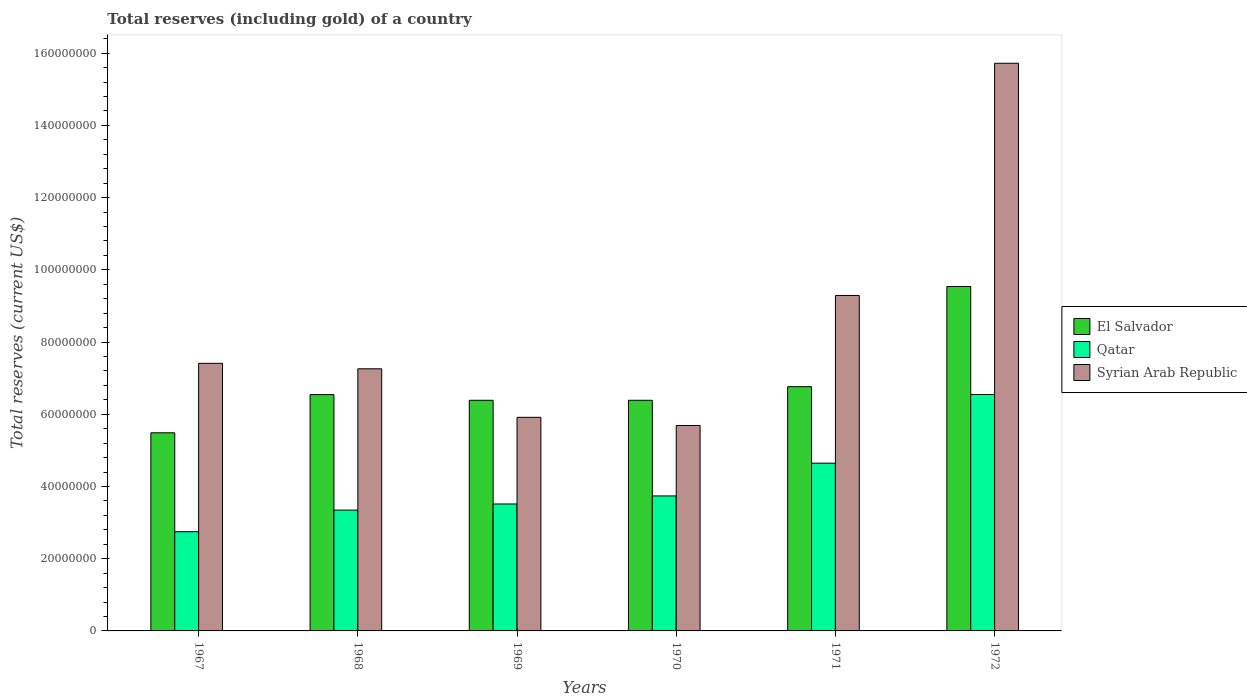How many groups of bars are there?
Ensure brevity in your answer.  6. Are the number of bars per tick equal to the number of legend labels?
Your answer should be compact. Yes. Are the number of bars on each tick of the X-axis equal?
Make the answer very short. Yes. What is the label of the 3rd group of bars from the left?
Ensure brevity in your answer.  1969. In how many cases, is the number of bars for a given year not equal to the number of legend labels?
Keep it short and to the point. 0. What is the total reserves (including gold) in Syrian Arab Republic in 1972?
Your answer should be compact. 1.57e+08. Across all years, what is the maximum total reserves (including gold) in Syrian Arab Republic?
Ensure brevity in your answer.  1.57e+08. Across all years, what is the minimum total reserves (including gold) in Syrian Arab Republic?
Provide a succinct answer. 5.69e+07. In which year was the total reserves (including gold) in Qatar maximum?
Offer a terse response. 1972. What is the total total reserves (including gold) in Syrian Arab Republic in the graph?
Keep it short and to the point. 5.13e+08. What is the difference between the total reserves (including gold) in Syrian Arab Republic in 1967 and that in 1972?
Your answer should be compact. -8.31e+07. What is the difference between the total reserves (including gold) in Qatar in 1968 and the total reserves (including gold) in Syrian Arab Republic in 1969?
Provide a short and direct response. -2.57e+07. What is the average total reserves (including gold) in Qatar per year?
Provide a short and direct response. 4.09e+07. In the year 1971, what is the difference between the total reserves (including gold) in El Salvador and total reserves (including gold) in Syrian Arab Republic?
Give a very brief answer. -2.53e+07. In how many years, is the total reserves (including gold) in Syrian Arab Republic greater than 24000000 US$?
Your answer should be very brief. 6. What is the ratio of the total reserves (including gold) in El Salvador in 1968 to that in 1971?
Your answer should be very brief. 0.97. What is the difference between the highest and the second highest total reserves (including gold) in Syrian Arab Republic?
Offer a very short reply. 6.43e+07. What is the difference between the highest and the lowest total reserves (including gold) in Syrian Arab Republic?
Provide a succinct answer. 1.00e+08. Is the sum of the total reserves (including gold) in Qatar in 1967 and 1972 greater than the maximum total reserves (including gold) in El Salvador across all years?
Offer a very short reply. No. What does the 3rd bar from the left in 1967 represents?
Provide a short and direct response. Syrian Arab Republic. What does the 2nd bar from the right in 1970 represents?
Offer a terse response. Qatar. How many bars are there?
Your response must be concise. 18. Are all the bars in the graph horizontal?
Your answer should be compact. No. Are the values on the major ticks of Y-axis written in scientific E-notation?
Provide a succinct answer. No. Does the graph contain any zero values?
Keep it short and to the point. No. Does the graph contain grids?
Ensure brevity in your answer.  No. Where does the legend appear in the graph?
Provide a short and direct response. Center right. How many legend labels are there?
Give a very brief answer. 3. How are the legend labels stacked?
Your answer should be very brief. Vertical. What is the title of the graph?
Provide a succinct answer. Total reserves (including gold) of a country. Does "Kosovo" appear as one of the legend labels in the graph?
Provide a succinct answer. No. What is the label or title of the Y-axis?
Offer a terse response. Total reserves (current US$). What is the Total reserves (current US$) in El Salvador in 1967?
Your response must be concise. 5.49e+07. What is the Total reserves (current US$) of Qatar in 1967?
Provide a short and direct response. 2.75e+07. What is the Total reserves (current US$) of Syrian Arab Republic in 1967?
Make the answer very short. 7.41e+07. What is the Total reserves (current US$) of El Salvador in 1968?
Keep it short and to the point. 6.54e+07. What is the Total reserves (current US$) of Qatar in 1968?
Make the answer very short. 3.35e+07. What is the Total reserves (current US$) of Syrian Arab Republic in 1968?
Your answer should be compact. 7.26e+07. What is the Total reserves (current US$) of El Salvador in 1969?
Make the answer very short. 6.39e+07. What is the Total reserves (current US$) of Qatar in 1969?
Provide a succinct answer. 3.52e+07. What is the Total reserves (current US$) in Syrian Arab Republic in 1969?
Provide a short and direct response. 5.92e+07. What is the Total reserves (current US$) of El Salvador in 1970?
Keep it short and to the point. 6.39e+07. What is the Total reserves (current US$) in Qatar in 1970?
Ensure brevity in your answer.  3.74e+07. What is the Total reserves (current US$) in Syrian Arab Republic in 1970?
Provide a short and direct response. 5.69e+07. What is the Total reserves (current US$) in El Salvador in 1971?
Give a very brief answer. 6.76e+07. What is the Total reserves (current US$) in Qatar in 1971?
Make the answer very short. 4.65e+07. What is the Total reserves (current US$) in Syrian Arab Republic in 1971?
Offer a terse response. 9.29e+07. What is the Total reserves (current US$) in El Salvador in 1972?
Offer a very short reply. 9.54e+07. What is the Total reserves (current US$) of Qatar in 1972?
Provide a succinct answer. 6.55e+07. What is the Total reserves (current US$) of Syrian Arab Republic in 1972?
Keep it short and to the point. 1.57e+08. Across all years, what is the maximum Total reserves (current US$) of El Salvador?
Your answer should be compact. 9.54e+07. Across all years, what is the maximum Total reserves (current US$) of Qatar?
Offer a very short reply. 6.55e+07. Across all years, what is the maximum Total reserves (current US$) in Syrian Arab Republic?
Make the answer very short. 1.57e+08. Across all years, what is the minimum Total reserves (current US$) in El Salvador?
Your response must be concise. 5.49e+07. Across all years, what is the minimum Total reserves (current US$) in Qatar?
Offer a very short reply. 2.75e+07. Across all years, what is the minimum Total reserves (current US$) of Syrian Arab Republic?
Provide a short and direct response. 5.69e+07. What is the total Total reserves (current US$) of El Salvador in the graph?
Offer a terse response. 4.11e+08. What is the total Total reserves (current US$) in Qatar in the graph?
Ensure brevity in your answer.  2.45e+08. What is the total Total reserves (current US$) of Syrian Arab Republic in the graph?
Make the answer very short. 5.13e+08. What is the difference between the Total reserves (current US$) of El Salvador in 1967 and that in 1968?
Your response must be concise. -1.06e+07. What is the difference between the Total reserves (current US$) in Qatar in 1967 and that in 1968?
Offer a very short reply. -5.99e+06. What is the difference between the Total reserves (current US$) in Syrian Arab Republic in 1967 and that in 1968?
Your answer should be compact. 1.51e+06. What is the difference between the Total reserves (current US$) of El Salvador in 1967 and that in 1969?
Your answer should be very brief. -9.00e+06. What is the difference between the Total reserves (current US$) in Qatar in 1967 and that in 1969?
Keep it short and to the point. -7.68e+06. What is the difference between the Total reserves (current US$) in Syrian Arab Republic in 1967 and that in 1969?
Provide a succinct answer. 1.50e+07. What is the difference between the Total reserves (current US$) of El Salvador in 1967 and that in 1970?
Keep it short and to the point. -9.00e+06. What is the difference between the Total reserves (current US$) of Qatar in 1967 and that in 1970?
Your response must be concise. -9.91e+06. What is the difference between the Total reserves (current US$) of Syrian Arab Republic in 1967 and that in 1970?
Your answer should be very brief. 1.72e+07. What is the difference between the Total reserves (current US$) of El Salvador in 1967 and that in 1971?
Your response must be concise. -1.28e+07. What is the difference between the Total reserves (current US$) of Qatar in 1967 and that in 1971?
Your response must be concise. -1.90e+07. What is the difference between the Total reserves (current US$) in Syrian Arab Republic in 1967 and that in 1971?
Ensure brevity in your answer.  -1.88e+07. What is the difference between the Total reserves (current US$) of El Salvador in 1967 and that in 1972?
Provide a succinct answer. -4.05e+07. What is the difference between the Total reserves (current US$) of Qatar in 1967 and that in 1972?
Your answer should be compact. -3.80e+07. What is the difference between the Total reserves (current US$) in Syrian Arab Republic in 1967 and that in 1972?
Offer a very short reply. -8.31e+07. What is the difference between the Total reserves (current US$) in El Salvador in 1968 and that in 1969?
Your response must be concise. 1.57e+06. What is the difference between the Total reserves (current US$) in Qatar in 1968 and that in 1969?
Your answer should be compact. -1.69e+06. What is the difference between the Total reserves (current US$) of Syrian Arab Republic in 1968 and that in 1969?
Offer a terse response. 1.34e+07. What is the difference between the Total reserves (current US$) in El Salvador in 1968 and that in 1970?
Provide a short and direct response. 1.57e+06. What is the difference between the Total reserves (current US$) of Qatar in 1968 and that in 1970?
Ensure brevity in your answer.  -3.92e+06. What is the difference between the Total reserves (current US$) in Syrian Arab Republic in 1968 and that in 1970?
Give a very brief answer. 1.57e+07. What is the difference between the Total reserves (current US$) in El Salvador in 1968 and that in 1971?
Provide a succinct answer. -2.20e+06. What is the difference between the Total reserves (current US$) in Qatar in 1968 and that in 1971?
Offer a very short reply. -1.30e+07. What is the difference between the Total reserves (current US$) of Syrian Arab Republic in 1968 and that in 1971?
Provide a succinct answer. -2.03e+07. What is the difference between the Total reserves (current US$) of El Salvador in 1968 and that in 1972?
Your answer should be very brief. -2.99e+07. What is the difference between the Total reserves (current US$) of Qatar in 1968 and that in 1972?
Provide a short and direct response. -3.20e+07. What is the difference between the Total reserves (current US$) of Syrian Arab Republic in 1968 and that in 1972?
Your answer should be very brief. -8.46e+07. What is the difference between the Total reserves (current US$) of El Salvador in 1969 and that in 1970?
Offer a very short reply. 203. What is the difference between the Total reserves (current US$) of Qatar in 1969 and that in 1970?
Your response must be concise. -2.23e+06. What is the difference between the Total reserves (current US$) of Syrian Arab Republic in 1969 and that in 1970?
Ensure brevity in your answer.  2.26e+06. What is the difference between the Total reserves (current US$) of El Salvador in 1969 and that in 1971?
Offer a terse response. -3.77e+06. What is the difference between the Total reserves (current US$) in Qatar in 1969 and that in 1971?
Offer a terse response. -1.13e+07. What is the difference between the Total reserves (current US$) of Syrian Arab Republic in 1969 and that in 1971?
Provide a succinct answer. -3.37e+07. What is the difference between the Total reserves (current US$) of El Salvador in 1969 and that in 1972?
Offer a terse response. -3.15e+07. What is the difference between the Total reserves (current US$) in Qatar in 1969 and that in 1972?
Your answer should be compact. -3.03e+07. What is the difference between the Total reserves (current US$) of Syrian Arab Republic in 1969 and that in 1972?
Provide a succinct answer. -9.81e+07. What is the difference between the Total reserves (current US$) of El Salvador in 1970 and that in 1971?
Give a very brief answer. -3.77e+06. What is the difference between the Total reserves (current US$) of Qatar in 1970 and that in 1971?
Your answer should be compact. -9.08e+06. What is the difference between the Total reserves (current US$) in Syrian Arab Republic in 1970 and that in 1971?
Your answer should be very brief. -3.60e+07. What is the difference between the Total reserves (current US$) of El Salvador in 1970 and that in 1972?
Offer a very short reply. -3.15e+07. What is the difference between the Total reserves (current US$) in Qatar in 1970 and that in 1972?
Keep it short and to the point. -2.81e+07. What is the difference between the Total reserves (current US$) in Syrian Arab Republic in 1970 and that in 1972?
Your answer should be compact. -1.00e+08. What is the difference between the Total reserves (current US$) of El Salvador in 1971 and that in 1972?
Your response must be concise. -2.77e+07. What is the difference between the Total reserves (current US$) of Qatar in 1971 and that in 1972?
Provide a succinct answer. -1.90e+07. What is the difference between the Total reserves (current US$) in Syrian Arab Republic in 1971 and that in 1972?
Make the answer very short. -6.43e+07. What is the difference between the Total reserves (current US$) in El Salvador in 1967 and the Total reserves (current US$) in Qatar in 1968?
Make the answer very short. 2.14e+07. What is the difference between the Total reserves (current US$) of El Salvador in 1967 and the Total reserves (current US$) of Syrian Arab Republic in 1968?
Offer a terse response. -1.77e+07. What is the difference between the Total reserves (current US$) in Qatar in 1967 and the Total reserves (current US$) in Syrian Arab Republic in 1968?
Make the answer very short. -4.51e+07. What is the difference between the Total reserves (current US$) in El Salvador in 1967 and the Total reserves (current US$) in Qatar in 1969?
Give a very brief answer. 1.97e+07. What is the difference between the Total reserves (current US$) in El Salvador in 1967 and the Total reserves (current US$) in Syrian Arab Republic in 1969?
Your response must be concise. -4.29e+06. What is the difference between the Total reserves (current US$) of Qatar in 1967 and the Total reserves (current US$) of Syrian Arab Republic in 1969?
Ensure brevity in your answer.  -3.17e+07. What is the difference between the Total reserves (current US$) of El Salvador in 1967 and the Total reserves (current US$) of Qatar in 1970?
Offer a terse response. 1.75e+07. What is the difference between the Total reserves (current US$) of El Salvador in 1967 and the Total reserves (current US$) of Syrian Arab Republic in 1970?
Your answer should be compact. -2.02e+06. What is the difference between the Total reserves (current US$) in Qatar in 1967 and the Total reserves (current US$) in Syrian Arab Republic in 1970?
Make the answer very short. -2.94e+07. What is the difference between the Total reserves (current US$) in El Salvador in 1967 and the Total reserves (current US$) in Qatar in 1971?
Keep it short and to the point. 8.41e+06. What is the difference between the Total reserves (current US$) in El Salvador in 1967 and the Total reserves (current US$) in Syrian Arab Republic in 1971?
Make the answer very short. -3.80e+07. What is the difference between the Total reserves (current US$) in Qatar in 1967 and the Total reserves (current US$) in Syrian Arab Republic in 1971?
Ensure brevity in your answer.  -6.54e+07. What is the difference between the Total reserves (current US$) in El Salvador in 1967 and the Total reserves (current US$) in Qatar in 1972?
Your answer should be very brief. -1.06e+07. What is the difference between the Total reserves (current US$) of El Salvador in 1967 and the Total reserves (current US$) of Syrian Arab Republic in 1972?
Make the answer very short. -1.02e+08. What is the difference between the Total reserves (current US$) of Qatar in 1967 and the Total reserves (current US$) of Syrian Arab Republic in 1972?
Your answer should be very brief. -1.30e+08. What is the difference between the Total reserves (current US$) of El Salvador in 1968 and the Total reserves (current US$) of Qatar in 1969?
Your answer should be very brief. 3.03e+07. What is the difference between the Total reserves (current US$) in El Salvador in 1968 and the Total reserves (current US$) in Syrian Arab Republic in 1969?
Ensure brevity in your answer.  6.29e+06. What is the difference between the Total reserves (current US$) in Qatar in 1968 and the Total reserves (current US$) in Syrian Arab Republic in 1969?
Ensure brevity in your answer.  -2.57e+07. What is the difference between the Total reserves (current US$) in El Salvador in 1968 and the Total reserves (current US$) in Qatar in 1970?
Your response must be concise. 2.81e+07. What is the difference between the Total reserves (current US$) of El Salvador in 1968 and the Total reserves (current US$) of Syrian Arab Republic in 1970?
Make the answer very short. 8.55e+06. What is the difference between the Total reserves (current US$) of Qatar in 1968 and the Total reserves (current US$) of Syrian Arab Republic in 1970?
Make the answer very short. -2.34e+07. What is the difference between the Total reserves (current US$) of El Salvador in 1968 and the Total reserves (current US$) of Qatar in 1971?
Provide a succinct answer. 1.90e+07. What is the difference between the Total reserves (current US$) of El Salvador in 1968 and the Total reserves (current US$) of Syrian Arab Republic in 1971?
Make the answer very short. -2.75e+07. What is the difference between the Total reserves (current US$) of Qatar in 1968 and the Total reserves (current US$) of Syrian Arab Republic in 1971?
Your response must be concise. -5.94e+07. What is the difference between the Total reserves (current US$) in El Salvador in 1968 and the Total reserves (current US$) in Qatar in 1972?
Give a very brief answer. -3.21e+04. What is the difference between the Total reserves (current US$) of El Salvador in 1968 and the Total reserves (current US$) of Syrian Arab Republic in 1972?
Give a very brief answer. -9.18e+07. What is the difference between the Total reserves (current US$) in Qatar in 1968 and the Total reserves (current US$) in Syrian Arab Republic in 1972?
Your answer should be very brief. -1.24e+08. What is the difference between the Total reserves (current US$) of El Salvador in 1969 and the Total reserves (current US$) of Qatar in 1970?
Offer a terse response. 2.65e+07. What is the difference between the Total reserves (current US$) in El Salvador in 1969 and the Total reserves (current US$) in Syrian Arab Republic in 1970?
Provide a short and direct response. 6.98e+06. What is the difference between the Total reserves (current US$) of Qatar in 1969 and the Total reserves (current US$) of Syrian Arab Republic in 1970?
Provide a short and direct response. -2.17e+07. What is the difference between the Total reserves (current US$) of El Salvador in 1969 and the Total reserves (current US$) of Qatar in 1971?
Keep it short and to the point. 1.74e+07. What is the difference between the Total reserves (current US$) of El Salvador in 1969 and the Total reserves (current US$) of Syrian Arab Republic in 1971?
Keep it short and to the point. -2.90e+07. What is the difference between the Total reserves (current US$) of Qatar in 1969 and the Total reserves (current US$) of Syrian Arab Republic in 1971?
Offer a terse response. -5.77e+07. What is the difference between the Total reserves (current US$) in El Salvador in 1969 and the Total reserves (current US$) in Qatar in 1972?
Ensure brevity in your answer.  -1.60e+06. What is the difference between the Total reserves (current US$) in El Salvador in 1969 and the Total reserves (current US$) in Syrian Arab Republic in 1972?
Ensure brevity in your answer.  -9.33e+07. What is the difference between the Total reserves (current US$) of Qatar in 1969 and the Total reserves (current US$) of Syrian Arab Republic in 1972?
Give a very brief answer. -1.22e+08. What is the difference between the Total reserves (current US$) in El Salvador in 1970 and the Total reserves (current US$) in Qatar in 1971?
Give a very brief answer. 1.74e+07. What is the difference between the Total reserves (current US$) in El Salvador in 1970 and the Total reserves (current US$) in Syrian Arab Republic in 1971?
Your answer should be very brief. -2.90e+07. What is the difference between the Total reserves (current US$) in Qatar in 1970 and the Total reserves (current US$) in Syrian Arab Republic in 1971?
Your response must be concise. -5.55e+07. What is the difference between the Total reserves (current US$) of El Salvador in 1970 and the Total reserves (current US$) of Qatar in 1972?
Give a very brief answer. -1.61e+06. What is the difference between the Total reserves (current US$) of El Salvador in 1970 and the Total reserves (current US$) of Syrian Arab Republic in 1972?
Your response must be concise. -9.33e+07. What is the difference between the Total reserves (current US$) of Qatar in 1970 and the Total reserves (current US$) of Syrian Arab Republic in 1972?
Make the answer very short. -1.20e+08. What is the difference between the Total reserves (current US$) in El Salvador in 1971 and the Total reserves (current US$) in Qatar in 1972?
Make the answer very short. 2.17e+06. What is the difference between the Total reserves (current US$) in El Salvador in 1971 and the Total reserves (current US$) in Syrian Arab Republic in 1972?
Offer a terse response. -8.96e+07. What is the difference between the Total reserves (current US$) of Qatar in 1971 and the Total reserves (current US$) of Syrian Arab Republic in 1972?
Provide a succinct answer. -1.11e+08. What is the average Total reserves (current US$) in El Salvador per year?
Your answer should be compact. 6.85e+07. What is the average Total reserves (current US$) of Qatar per year?
Provide a short and direct response. 4.09e+07. What is the average Total reserves (current US$) in Syrian Arab Republic per year?
Give a very brief answer. 8.55e+07. In the year 1967, what is the difference between the Total reserves (current US$) in El Salvador and Total reserves (current US$) in Qatar?
Provide a succinct answer. 2.74e+07. In the year 1967, what is the difference between the Total reserves (current US$) in El Salvador and Total reserves (current US$) in Syrian Arab Republic?
Give a very brief answer. -1.92e+07. In the year 1967, what is the difference between the Total reserves (current US$) in Qatar and Total reserves (current US$) in Syrian Arab Republic?
Provide a short and direct response. -4.66e+07. In the year 1968, what is the difference between the Total reserves (current US$) of El Salvador and Total reserves (current US$) of Qatar?
Provide a succinct answer. 3.20e+07. In the year 1968, what is the difference between the Total reserves (current US$) of El Salvador and Total reserves (current US$) of Syrian Arab Republic?
Make the answer very short. -7.15e+06. In the year 1968, what is the difference between the Total reserves (current US$) in Qatar and Total reserves (current US$) in Syrian Arab Republic?
Provide a succinct answer. -3.91e+07. In the year 1969, what is the difference between the Total reserves (current US$) of El Salvador and Total reserves (current US$) of Qatar?
Make the answer very short. 2.87e+07. In the year 1969, what is the difference between the Total reserves (current US$) in El Salvador and Total reserves (current US$) in Syrian Arab Republic?
Offer a very short reply. 4.71e+06. In the year 1969, what is the difference between the Total reserves (current US$) in Qatar and Total reserves (current US$) in Syrian Arab Republic?
Give a very brief answer. -2.40e+07. In the year 1970, what is the difference between the Total reserves (current US$) of El Salvador and Total reserves (current US$) of Qatar?
Provide a succinct answer. 2.65e+07. In the year 1970, what is the difference between the Total reserves (current US$) of El Salvador and Total reserves (current US$) of Syrian Arab Republic?
Your response must be concise. 6.98e+06. In the year 1970, what is the difference between the Total reserves (current US$) of Qatar and Total reserves (current US$) of Syrian Arab Republic?
Offer a terse response. -1.95e+07. In the year 1971, what is the difference between the Total reserves (current US$) in El Salvador and Total reserves (current US$) in Qatar?
Your response must be concise. 2.12e+07. In the year 1971, what is the difference between the Total reserves (current US$) in El Salvador and Total reserves (current US$) in Syrian Arab Republic?
Your answer should be compact. -2.53e+07. In the year 1971, what is the difference between the Total reserves (current US$) of Qatar and Total reserves (current US$) of Syrian Arab Republic?
Offer a terse response. -4.64e+07. In the year 1972, what is the difference between the Total reserves (current US$) in El Salvador and Total reserves (current US$) in Qatar?
Ensure brevity in your answer.  2.99e+07. In the year 1972, what is the difference between the Total reserves (current US$) of El Salvador and Total reserves (current US$) of Syrian Arab Republic?
Offer a very short reply. -6.18e+07. In the year 1972, what is the difference between the Total reserves (current US$) in Qatar and Total reserves (current US$) in Syrian Arab Republic?
Make the answer very short. -9.17e+07. What is the ratio of the Total reserves (current US$) of El Salvador in 1967 to that in 1968?
Your response must be concise. 0.84. What is the ratio of the Total reserves (current US$) in Qatar in 1967 to that in 1968?
Offer a terse response. 0.82. What is the ratio of the Total reserves (current US$) in Syrian Arab Republic in 1967 to that in 1968?
Offer a very short reply. 1.02. What is the ratio of the Total reserves (current US$) in El Salvador in 1967 to that in 1969?
Offer a very short reply. 0.86. What is the ratio of the Total reserves (current US$) of Qatar in 1967 to that in 1969?
Your response must be concise. 0.78. What is the ratio of the Total reserves (current US$) in Syrian Arab Republic in 1967 to that in 1969?
Ensure brevity in your answer.  1.25. What is the ratio of the Total reserves (current US$) in El Salvador in 1967 to that in 1970?
Offer a terse response. 0.86. What is the ratio of the Total reserves (current US$) in Qatar in 1967 to that in 1970?
Provide a succinct answer. 0.73. What is the ratio of the Total reserves (current US$) of Syrian Arab Republic in 1967 to that in 1970?
Your answer should be very brief. 1.3. What is the ratio of the Total reserves (current US$) of El Salvador in 1967 to that in 1971?
Ensure brevity in your answer.  0.81. What is the ratio of the Total reserves (current US$) of Qatar in 1967 to that in 1971?
Provide a short and direct response. 0.59. What is the ratio of the Total reserves (current US$) of Syrian Arab Republic in 1967 to that in 1971?
Keep it short and to the point. 0.8. What is the ratio of the Total reserves (current US$) in El Salvador in 1967 to that in 1972?
Ensure brevity in your answer.  0.58. What is the ratio of the Total reserves (current US$) of Qatar in 1967 to that in 1972?
Offer a terse response. 0.42. What is the ratio of the Total reserves (current US$) of Syrian Arab Republic in 1967 to that in 1972?
Keep it short and to the point. 0.47. What is the ratio of the Total reserves (current US$) of El Salvador in 1968 to that in 1969?
Your response must be concise. 1.02. What is the ratio of the Total reserves (current US$) of Qatar in 1968 to that in 1969?
Offer a terse response. 0.95. What is the ratio of the Total reserves (current US$) in Syrian Arab Republic in 1968 to that in 1969?
Your response must be concise. 1.23. What is the ratio of the Total reserves (current US$) of El Salvador in 1968 to that in 1970?
Keep it short and to the point. 1.02. What is the ratio of the Total reserves (current US$) of Qatar in 1968 to that in 1970?
Make the answer very short. 0.9. What is the ratio of the Total reserves (current US$) in Syrian Arab Republic in 1968 to that in 1970?
Offer a very short reply. 1.28. What is the ratio of the Total reserves (current US$) in El Salvador in 1968 to that in 1971?
Give a very brief answer. 0.97. What is the ratio of the Total reserves (current US$) in Qatar in 1968 to that in 1971?
Make the answer very short. 0.72. What is the ratio of the Total reserves (current US$) in Syrian Arab Republic in 1968 to that in 1971?
Offer a terse response. 0.78. What is the ratio of the Total reserves (current US$) of El Salvador in 1968 to that in 1972?
Provide a succinct answer. 0.69. What is the ratio of the Total reserves (current US$) in Qatar in 1968 to that in 1972?
Provide a short and direct response. 0.51. What is the ratio of the Total reserves (current US$) of Syrian Arab Republic in 1968 to that in 1972?
Make the answer very short. 0.46. What is the ratio of the Total reserves (current US$) in Qatar in 1969 to that in 1970?
Make the answer very short. 0.94. What is the ratio of the Total reserves (current US$) in Syrian Arab Republic in 1969 to that in 1970?
Make the answer very short. 1.04. What is the ratio of the Total reserves (current US$) of El Salvador in 1969 to that in 1971?
Offer a very short reply. 0.94. What is the ratio of the Total reserves (current US$) in Qatar in 1969 to that in 1971?
Your answer should be compact. 0.76. What is the ratio of the Total reserves (current US$) of Syrian Arab Republic in 1969 to that in 1971?
Make the answer very short. 0.64. What is the ratio of the Total reserves (current US$) of El Salvador in 1969 to that in 1972?
Ensure brevity in your answer.  0.67. What is the ratio of the Total reserves (current US$) in Qatar in 1969 to that in 1972?
Keep it short and to the point. 0.54. What is the ratio of the Total reserves (current US$) of Syrian Arab Republic in 1969 to that in 1972?
Your response must be concise. 0.38. What is the ratio of the Total reserves (current US$) of El Salvador in 1970 to that in 1971?
Provide a short and direct response. 0.94. What is the ratio of the Total reserves (current US$) of Qatar in 1970 to that in 1971?
Your answer should be compact. 0.8. What is the ratio of the Total reserves (current US$) of Syrian Arab Republic in 1970 to that in 1971?
Ensure brevity in your answer.  0.61. What is the ratio of the Total reserves (current US$) of El Salvador in 1970 to that in 1972?
Keep it short and to the point. 0.67. What is the ratio of the Total reserves (current US$) in Qatar in 1970 to that in 1972?
Give a very brief answer. 0.57. What is the ratio of the Total reserves (current US$) of Syrian Arab Republic in 1970 to that in 1972?
Provide a succinct answer. 0.36. What is the ratio of the Total reserves (current US$) in El Salvador in 1971 to that in 1972?
Give a very brief answer. 0.71. What is the ratio of the Total reserves (current US$) of Qatar in 1971 to that in 1972?
Your answer should be very brief. 0.71. What is the ratio of the Total reserves (current US$) in Syrian Arab Republic in 1971 to that in 1972?
Offer a very short reply. 0.59. What is the difference between the highest and the second highest Total reserves (current US$) of El Salvador?
Your answer should be very brief. 2.77e+07. What is the difference between the highest and the second highest Total reserves (current US$) of Qatar?
Offer a very short reply. 1.90e+07. What is the difference between the highest and the second highest Total reserves (current US$) in Syrian Arab Republic?
Offer a very short reply. 6.43e+07. What is the difference between the highest and the lowest Total reserves (current US$) in El Salvador?
Make the answer very short. 4.05e+07. What is the difference between the highest and the lowest Total reserves (current US$) in Qatar?
Give a very brief answer. 3.80e+07. What is the difference between the highest and the lowest Total reserves (current US$) of Syrian Arab Republic?
Make the answer very short. 1.00e+08. 